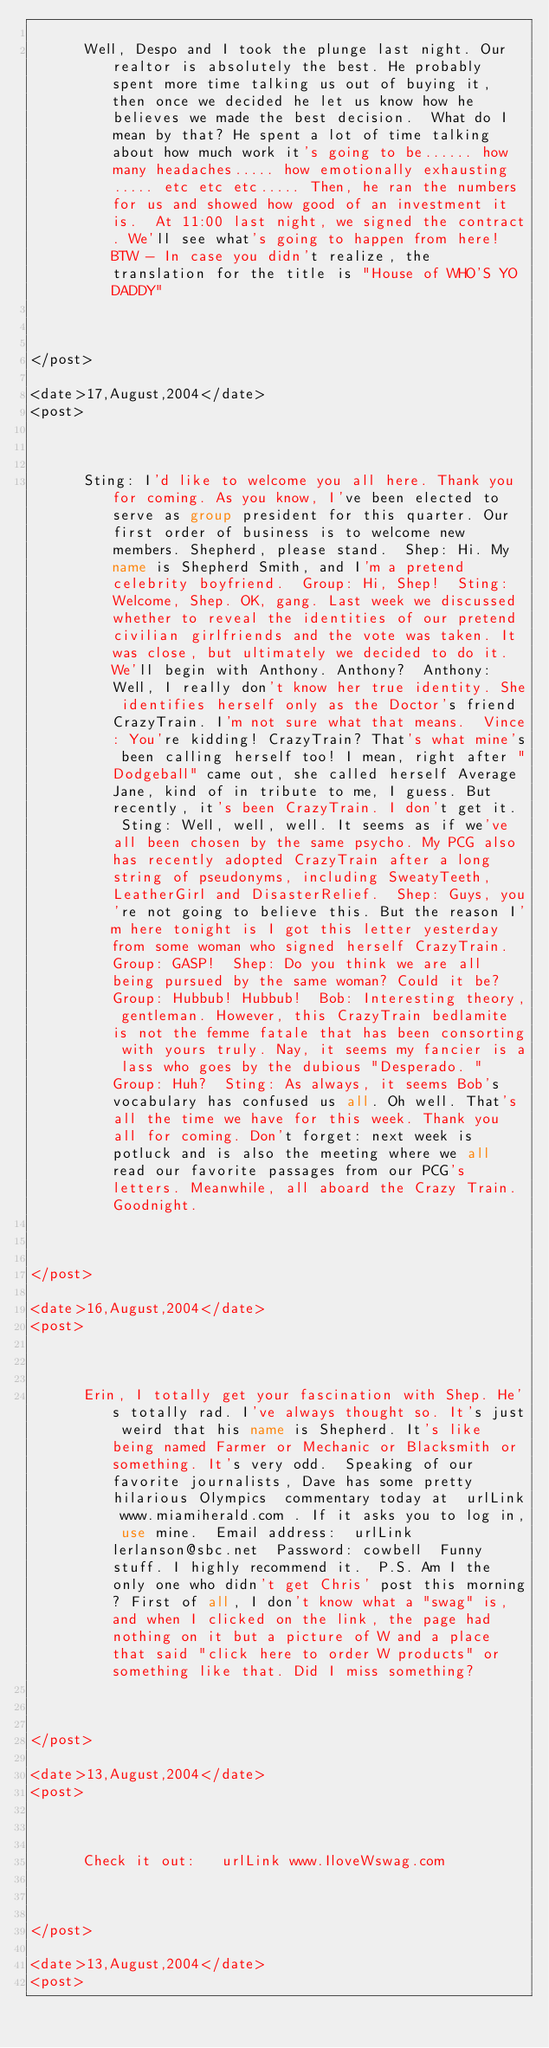Convert code to text. <code><loc_0><loc_0><loc_500><loc_500><_XML_>       
      Well, Despo and I took the plunge last night. Our realtor is absolutely the best. He probably spent more time talking us out of buying it, then once we decided he let us know how he believes we made the best decision.  What do I mean by that? He spent a lot of time talking about how much work it's going to be...... how many headaches..... how emotionally exhausting..... etc etc etc..... Then, he ran the numbers for us and showed how good of an investment it is.  At 11:00 last night, we signed the contract. We'll see what's going to happen from here!  BTW - In case you didn't realize, the translation for the title is "House of WHO'S YO DADDY"  
     

    
</post>

<date>17,August,2004</date>
<post>


       
      Sting: I'd like to welcome you all here. Thank you for coming. As you know, I've been elected to serve as group president for this quarter. Our first order of business is to welcome new members. Shepherd, please stand.  Shep: Hi. My name is Shepherd Smith, and I'm a pretend celebrity boyfriend.  Group: Hi, Shep!  Sting: Welcome, Shep. OK, gang. Last week we discussed whether to reveal the identities of our pretend civilian girlfriends and the vote was taken. It was close, but ultimately we decided to do it. We'll begin with Anthony. Anthony?  Anthony: Well, I really don't know her true identity. She identifies herself only as the Doctor's friend CrazyTrain. I'm not sure what that means.  Vince: You're kidding! CrazyTrain? That's what mine's been calling herself too! I mean, right after "Dodgeball" came out, she called herself Average Jane, kind of in tribute to me, I guess. But recently, it's been CrazyTrain. I don't get it.  Sting: Well, well, well. It seems as if we've all been chosen by the same psycho. My PCG also has recently adopted CrazyTrain after a long string of pseudonyms, including SweatyTeeth, LeatherGirl and DisasterRelief.  Shep: Guys, you're not going to believe this. But the reason I'm here tonight is I got this letter yesterday from some woman who signed herself CrazyTrain.  Group: GASP!  Shep: Do you think we are all being pursued by the same woman? Could it be?  Group: Hubbub! Hubbub!  Bob: Interesting theory, gentleman. However, this CrazyTrain bedlamite is not the femme fatale that has been consorting with yours truly. Nay, it seems my fancier is a lass who goes by the dubious "Desperado. "  Group: Huh?  Sting: As always, it seems Bob's vocabulary has confused us all. Oh well. That's all the time we have for this week. Thank you all for coming. Don't forget: next week is potluck and is also the meeting where we all read our favorite passages from our PCG's letters. Meanwhile, all aboard the Crazy Train. Goodnight. 
     

    
</post>

<date>16,August,2004</date>
<post>


       
      Erin, I totally get your fascination with Shep. He's totally rad. I've always thought so. It's just weird that his name is Shepherd. It's like being named Farmer or Mechanic or Blacksmith or something. It's very odd.  Speaking of our favorite journalists, Dave has some pretty hilarious Olympics  commentary today at  urlLink www.miamiherald.com . If it asks you to log in, use mine.  Email address:  urlLink lerlanson@sbc.net  Password: cowbell  Funny stuff. I highly recommend it.  P.S. Am I the only one who didn't get Chris' post this morning? First of all, I don't know what a "swag" is, and when I clicked on the link, the page had nothing on it but a picture of W and a place that said "click here to order W products" or something like that. Did I miss something?   
     

    
</post>

<date>13,August,2004</date>
<post>


       
      Check it out:   urlLink www.IloveWswag.com  
     

    
</post>

<date>13,August,2004</date>
<post>


       </code> 